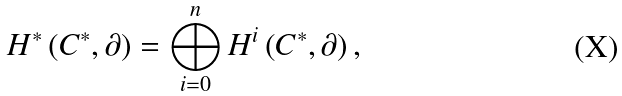Convert formula to latex. <formula><loc_0><loc_0><loc_500><loc_500>H ^ { * } \left ( C ^ { * } , \partial \right ) = \bigoplus _ { i = 0 } ^ { n } H ^ { i } \left ( C ^ { * } , \partial \right ) ,</formula> 